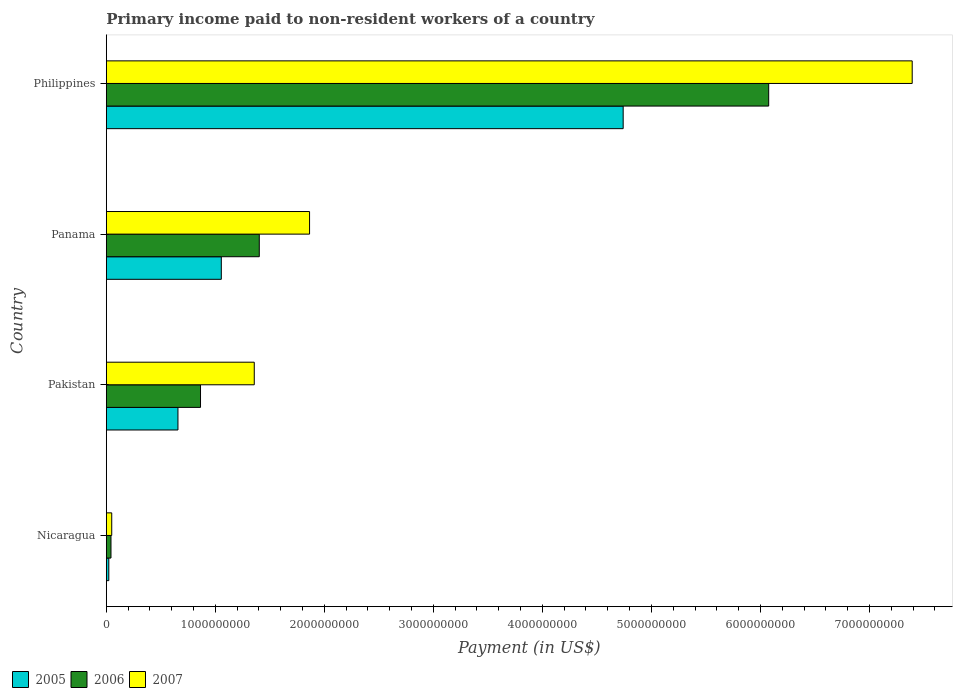How many groups of bars are there?
Offer a very short reply. 4. How many bars are there on the 4th tick from the top?
Your answer should be very brief. 3. How many bars are there on the 1st tick from the bottom?
Your answer should be compact. 3. What is the label of the 2nd group of bars from the top?
Ensure brevity in your answer.  Panama. What is the amount paid to workers in 2007 in Panama?
Keep it short and to the point. 1.86e+09. Across all countries, what is the maximum amount paid to workers in 2007?
Your answer should be compact. 7.39e+09. Across all countries, what is the minimum amount paid to workers in 2005?
Your response must be concise. 2.27e+07. In which country was the amount paid to workers in 2006 maximum?
Keep it short and to the point. Philippines. In which country was the amount paid to workers in 2007 minimum?
Offer a very short reply. Nicaragua. What is the total amount paid to workers in 2006 in the graph?
Offer a very short reply. 8.39e+09. What is the difference between the amount paid to workers in 2007 in Pakistan and that in Philippines?
Ensure brevity in your answer.  -6.04e+09. What is the difference between the amount paid to workers in 2006 in Nicaragua and the amount paid to workers in 2007 in Philippines?
Offer a very short reply. -7.35e+09. What is the average amount paid to workers in 2005 per country?
Give a very brief answer. 1.62e+09. What is the difference between the amount paid to workers in 2006 and amount paid to workers in 2007 in Nicaragua?
Offer a terse response. -7.00e+06. In how many countries, is the amount paid to workers in 2007 greater than 6600000000 US$?
Offer a very short reply. 1. What is the ratio of the amount paid to workers in 2006 in Nicaragua to that in Philippines?
Your answer should be very brief. 0.01. Is the amount paid to workers in 2005 in Nicaragua less than that in Panama?
Your response must be concise. Yes. Is the difference between the amount paid to workers in 2006 in Pakistan and Panama greater than the difference between the amount paid to workers in 2007 in Pakistan and Panama?
Offer a very short reply. No. What is the difference between the highest and the second highest amount paid to workers in 2006?
Provide a succinct answer. 4.67e+09. What is the difference between the highest and the lowest amount paid to workers in 2007?
Provide a short and direct response. 7.34e+09. Is it the case that in every country, the sum of the amount paid to workers in 2006 and amount paid to workers in 2007 is greater than the amount paid to workers in 2005?
Your response must be concise. Yes. How many bars are there?
Ensure brevity in your answer.  12. How many countries are there in the graph?
Your response must be concise. 4. What is the difference between two consecutive major ticks on the X-axis?
Ensure brevity in your answer.  1.00e+09. Are the values on the major ticks of X-axis written in scientific E-notation?
Keep it short and to the point. No. Does the graph contain any zero values?
Offer a terse response. No. Where does the legend appear in the graph?
Offer a terse response. Bottom left. How many legend labels are there?
Give a very brief answer. 3. What is the title of the graph?
Offer a terse response. Primary income paid to non-resident workers of a country. Does "2015" appear as one of the legend labels in the graph?
Your response must be concise. No. What is the label or title of the X-axis?
Your answer should be compact. Payment (in US$). What is the Payment (in US$) in 2005 in Nicaragua?
Offer a terse response. 2.27e+07. What is the Payment (in US$) in 2006 in Nicaragua?
Offer a very short reply. 4.26e+07. What is the Payment (in US$) of 2007 in Nicaragua?
Your response must be concise. 4.96e+07. What is the Payment (in US$) of 2005 in Pakistan?
Keep it short and to the point. 6.57e+08. What is the Payment (in US$) of 2006 in Pakistan?
Your answer should be very brief. 8.64e+08. What is the Payment (in US$) of 2007 in Pakistan?
Your answer should be very brief. 1.36e+09. What is the Payment (in US$) in 2005 in Panama?
Offer a terse response. 1.05e+09. What is the Payment (in US$) of 2006 in Panama?
Ensure brevity in your answer.  1.40e+09. What is the Payment (in US$) of 2007 in Panama?
Offer a terse response. 1.86e+09. What is the Payment (in US$) of 2005 in Philippines?
Your answer should be compact. 4.74e+09. What is the Payment (in US$) of 2006 in Philippines?
Make the answer very short. 6.08e+09. What is the Payment (in US$) in 2007 in Philippines?
Provide a succinct answer. 7.39e+09. Across all countries, what is the maximum Payment (in US$) of 2005?
Keep it short and to the point. 4.74e+09. Across all countries, what is the maximum Payment (in US$) of 2006?
Your answer should be very brief. 6.08e+09. Across all countries, what is the maximum Payment (in US$) in 2007?
Provide a succinct answer. 7.39e+09. Across all countries, what is the minimum Payment (in US$) in 2005?
Your response must be concise. 2.27e+07. Across all countries, what is the minimum Payment (in US$) in 2006?
Provide a succinct answer. 4.26e+07. Across all countries, what is the minimum Payment (in US$) in 2007?
Your response must be concise. 4.96e+07. What is the total Payment (in US$) of 2005 in the graph?
Ensure brevity in your answer.  6.48e+09. What is the total Payment (in US$) of 2006 in the graph?
Ensure brevity in your answer.  8.39e+09. What is the total Payment (in US$) of 2007 in the graph?
Provide a short and direct response. 1.07e+1. What is the difference between the Payment (in US$) in 2005 in Nicaragua and that in Pakistan?
Make the answer very short. -6.34e+08. What is the difference between the Payment (in US$) of 2006 in Nicaragua and that in Pakistan?
Give a very brief answer. -8.21e+08. What is the difference between the Payment (in US$) of 2007 in Nicaragua and that in Pakistan?
Ensure brevity in your answer.  -1.31e+09. What is the difference between the Payment (in US$) of 2005 in Nicaragua and that in Panama?
Offer a very short reply. -1.03e+09. What is the difference between the Payment (in US$) in 2006 in Nicaragua and that in Panama?
Make the answer very short. -1.36e+09. What is the difference between the Payment (in US$) of 2007 in Nicaragua and that in Panama?
Give a very brief answer. -1.81e+09. What is the difference between the Payment (in US$) in 2005 in Nicaragua and that in Philippines?
Keep it short and to the point. -4.72e+09. What is the difference between the Payment (in US$) in 2006 in Nicaragua and that in Philippines?
Keep it short and to the point. -6.03e+09. What is the difference between the Payment (in US$) of 2007 in Nicaragua and that in Philippines?
Your response must be concise. -7.34e+09. What is the difference between the Payment (in US$) in 2005 in Pakistan and that in Panama?
Your response must be concise. -3.98e+08. What is the difference between the Payment (in US$) of 2006 in Pakistan and that in Panama?
Ensure brevity in your answer.  -5.39e+08. What is the difference between the Payment (in US$) in 2007 in Pakistan and that in Panama?
Offer a terse response. -5.07e+08. What is the difference between the Payment (in US$) in 2005 in Pakistan and that in Philippines?
Offer a terse response. -4.08e+09. What is the difference between the Payment (in US$) of 2006 in Pakistan and that in Philippines?
Keep it short and to the point. -5.21e+09. What is the difference between the Payment (in US$) of 2007 in Pakistan and that in Philippines?
Provide a succinct answer. -6.04e+09. What is the difference between the Payment (in US$) in 2005 in Panama and that in Philippines?
Provide a succinct answer. -3.69e+09. What is the difference between the Payment (in US$) in 2006 in Panama and that in Philippines?
Offer a very short reply. -4.67e+09. What is the difference between the Payment (in US$) of 2007 in Panama and that in Philippines?
Your response must be concise. -5.53e+09. What is the difference between the Payment (in US$) of 2005 in Nicaragua and the Payment (in US$) of 2006 in Pakistan?
Give a very brief answer. -8.41e+08. What is the difference between the Payment (in US$) in 2005 in Nicaragua and the Payment (in US$) in 2007 in Pakistan?
Your answer should be very brief. -1.33e+09. What is the difference between the Payment (in US$) of 2006 in Nicaragua and the Payment (in US$) of 2007 in Pakistan?
Offer a terse response. -1.31e+09. What is the difference between the Payment (in US$) of 2005 in Nicaragua and the Payment (in US$) of 2006 in Panama?
Offer a terse response. -1.38e+09. What is the difference between the Payment (in US$) of 2005 in Nicaragua and the Payment (in US$) of 2007 in Panama?
Your answer should be very brief. -1.84e+09. What is the difference between the Payment (in US$) of 2006 in Nicaragua and the Payment (in US$) of 2007 in Panama?
Provide a short and direct response. -1.82e+09. What is the difference between the Payment (in US$) in 2005 in Nicaragua and the Payment (in US$) in 2006 in Philippines?
Offer a very short reply. -6.05e+09. What is the difference between the Payment (in US$) in 2005 in Nicaragua and the Payment (in US$) in 2007 in Philippines?
Offer a very short reply. -7.37e+09. What is the difference between the Payment (in US$) in 2006 in Nicaragua and the Payment (in US$) in 2007 in Philippines?
Provide a succinct answer. -7.35e+09. What is the difference between the Payment (in US$) in 2005 in Pakistan and the Payment (in US$) in 2006 in Panama?
Ensure brevity in your answer.  -7.46e+08. What is the difference between the Payment (in US$) in 2005 in Pakistan and the Payment (in US$) in 2007 in Panama?
Provide a short and direct response. -1.21e+09. What is the difference between the Payment (in US$) of 2006 in Pakistan and the Payment (in US$) of 2007 in Panama?
Provide a short and direct response. -1.00e+09. What is the difference between the Payment (in US$) of 2005 in Pakistan and the Payment (in US$) of 2006 in Philippines?
Your answer should be very brief. -5.42e+09. What is the difference between the Payment (in US$) in 2005 in Pakistan and the Payment (in US$) in 2007 in Philippines?
Offer a very short reply. -6.74e+09. What is the difference between the Payment (in US$) of 2006 in Pakistan and the Payment (in US$) of 2007 in Philippines?
Keep it short and to the point. -6.53e+09. What is the difference between the Payment (in US$) in 2005 in Panama and the Payment (in US$) in 2006 in Philippines?
Give a very brief answer. -5.02e+09. What is the difference between the Payment (in US$) of 2005 in Panama and the Payment (in US$) of 2007 in Philippines?
Ensure brevity in your answer.  -6.34e+09. What is the difference between the Payment (in US$) of 2006 in Panama and the Payment (in US$) of 2007 in Philippines?
Provide a short and direct response. -5.99e+09. What is the average Payment (in US$) of 2005 per country?
Keep it short and to the point. 1.62e+09. What is the average Payment (in US$) of 2006 per country?
Your response must be concise. 2.10e+09. What is the average Payment (in US$) of 2007 per country?
Your response must be concise. 2.67e+09. What is the difference between the Payment (in US$) in 2005 and Payment (in US$) in 2006 in Nicaragua?
Provide a succinct answer. -1.99e+07. What is the difference between the Payment (in US$) in 2005 and Payment (in US$) in 2007 in Nicaragua?
Offer a terse response. -2.69e+07. What is the difference between the Payment (in US$) of 2006 and Payment (in US$) of 2007 in Nicaragua?
Your answer should be very brief. -7.00e+06. What is the difference between the Payment (in US$) of 2005 and Payment (in US$) of 2006 in Pakistan?
Keep it short and to the point. -2.07e+08. What is the difference between the Payment (in US$) of 2005 and Payment (in US$) of 2007 in Pakistan?
Your answer should be very brief. -7.00e+08. What is the difference between the Payment (in US$) of 2006 and Payment (in US$) of 2007 in Pakistan?
Your answer should be compact. -4.93e+08. What is the difference between the Payment (in US$) of 2005 and Payment (in US$) of 2006 in Panama?
Offer a very short reply. -3.48e+08. What is the difference between the Payment (in US$) of 2005 and Payment (in US$) of 2007 in Panama?
Give a very brief answer. -8.09e+08. What is the difference between the Payment (in US$) of 2006 and Payment (in US$) of 2007 in Panama?
Your answer should be very brief. -4.61e+08. What is the difference between the Payment (in US$) in 2005 and Payment (in US$) in 2006 in Philippines?
Make the answer very short. -1.33e+09. What is the difference between the Payment (in US$) in 2005 and Payment (in US$) in 2007 in Philippines?
Provide a succinct answer. -2.65e+09. What is the difference between the Payment (in US$) in 2006 and Payment (in US$) in 2007 in Philippines?
Your answer should be very brief. -1.32e+09. What is the ratio of the Payment (in US$) in 2005 in Nicaragua to that in Pakistan?
Keep it short and to the point. 0.03. What is the ratio of the Payment (in US$) in 2006 in Nicaragua to that in Pakistan?
Give a very brief answer. 0.05. What is the ratio of the Payment (in US$) in 2007 in Nicaragua to that in Pakistan?
Ensure brevity in your answer.  0.04. What is the ratio of the Payment (in US$) of 2005 in Nicaragua to that in Panama?
Keep it short and to the point. 0.02. What is the ratio of the Payment (in US$) of 2006 in Nicaragua to that in Panama?
Provide a short and direct response. 0.03. What is the ratio of the Payment (in US$) of 2007 in Nicaragua to that in Panama?
Give a very brief answer. 0.03. What is the ratio of the Payment (in US$) in 2005 in Nicaragua to that in Philippines?
Provide a succinct answer. 0. What is the ratio of the Payment (in US$) of 2006 in Nicaragua to that in Philippines?
Your answer should be very brief. 0.01. What is the ratio of the Payment (in US$) in 2007 in Nicaragua to that in Philippines?
Make the answer very short. 0.01. What is the ratio of the Payment (in US$) in 2005 in Pakistan to that in Panama?
Your answer should be compact. 0.62. What is the ratio of the Payment (in US$) in 2006 in Pakistan to that in Panama?
Offer a very short reply. 0.62. What is the ratio of the Payment (in US$) in 2007 in Pakistan to that in Panama?
Your answer should be very brief. 0.73. What is the ratio of the Payment (in US$) in 2005 in Pakistan to that in Philippines?
Provide a succinct answer. 0.14. What is the ratio of the Payment (in US$) in 2006 in Pakistan to that in Philippines?
Your response must be concise. 0.14. What is the ratio of the Payment (in US$) of 2007 in Pakistan to that in Philippines?
Make the answer very short. 0.18. What is the ratio of the Payment (in US$) in 2005 in Panama to that in Philippines?
Provide a short and direct response. 0.22. What is the ratio of the Payment (in US$) of 2006 in Panama to that in Philippines?
Keep it short and to the point. 0.23. What is the ratio of the Payment (in US$) of 2007 in Panama to that in Philippines?
Your answer should be compact. 0.25. What is the difference between the highest and the second highest Payment (in US$) of 2005?
Provide a short and direct response. 3.69e+09. What is the difference between the highest and the second highest Payment (in US$) of 2006?
Give a very brief answer. 4.67e+09. What is the difference between the highest and the second highest Payment (in US$) of 2007?
Offer a very short reply. 5.53e+09. What is the difference between the highest and the lowest Payment (in US$) of 2005?
Make the answer very short. 4.72e+09. What is the difference between the highest and the lowest Payment (in US$) in 2006?
Give a very brief answer. 6.03e+09. What is the difference between the highest and the lowest Payment (in US$) in 2007?
Make the answer very short. 7.34e+09. 